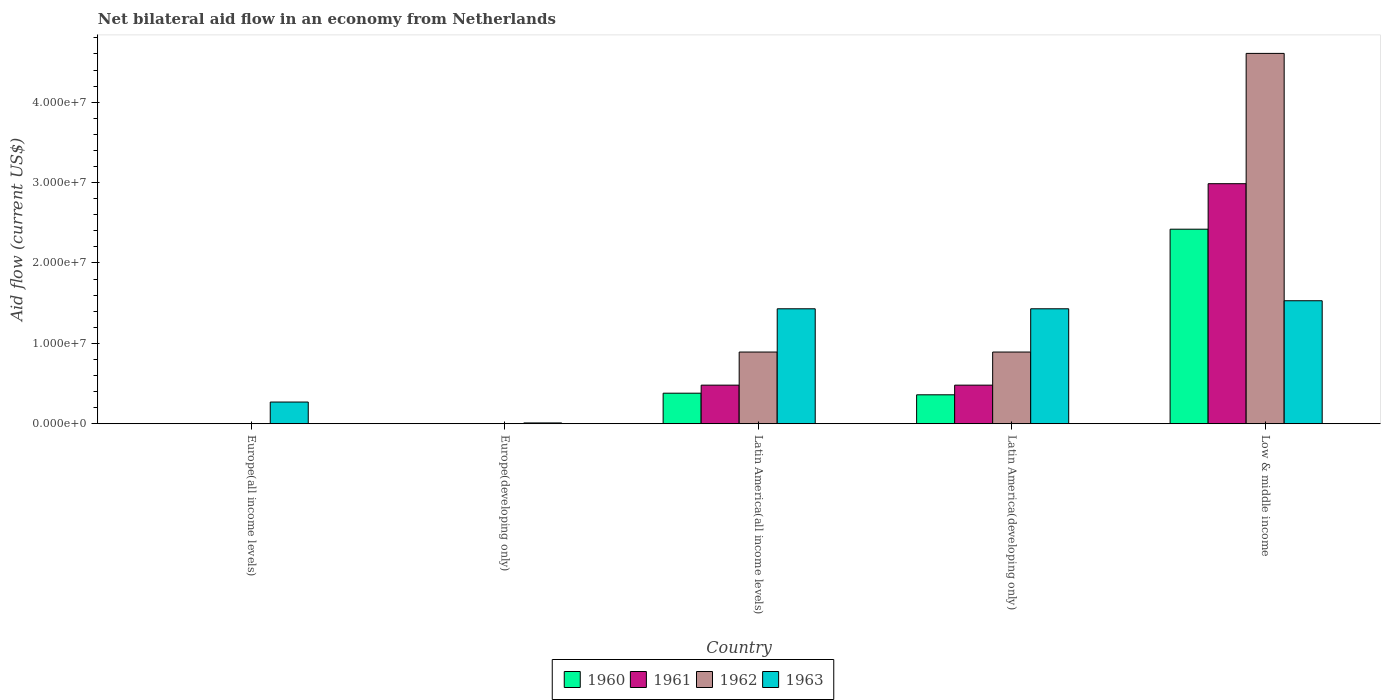Are the number of bars on each tick of the X-axis equal?
Offer a very short reply. No. How many bars are there on the 5th tick from the right?
Provide a succinct answer. 1. What is the label of the 3rd group of bars from the left?
Your answer should be very brief. Latin America(all income levels). In how many cases, is the number of bars for a given country not equal to the number of legend labels?
Keep it short and to the point. 2. Across all countries, what is the maximum net bilateral aid flow in 1961?
Provide a succinct answer. 2.99e+07. Across all countries, what is the minimum net bilateral aid flow in 1962?
Your response must be concise. 0. What is the total net bilateral aid flow in 1960 in the graph?
Provide a succinct answer. 3.16e+07. What is the difference between the net bilateral aid flow in 1963 in Europe(all income levels) and that in Latin America(developing only)?
Provide a succinct answer. -1.16e+07. What is the difference between the net bilateral aid flow in 1963 in Europe(all income levels) and the net bilateral aid flow in 1961 in Low & middle income?
Your answer should be very brief. -2.72e+07. What is the average net bilateral aid flow in 1962 per country?
Offer a very short reply. 1.28e+07. What is the difference between the net bilateral aid flow of/in 1962 and net bilateral aid flow of/in 1963 in Low & middle income?
Ensure brevity in your answer.  3.08e+07. In how many countries, is the net bilateral aid flow in 1963 greater than 20000000 US$?
Your response must be concise. 0. What is the difference between the highest and the second highest net bilateral aid flow in 1963?
Your answer should be very brief. 1.00e+06. What is the difference between the highest and the lowest net bilateral aid flow in 1961?
Offer a very short reply. 2.99e+07. In how many countries, is the net bilateral aid flow in 1961 greater than the average net bilateral aid flow in 1961 taken over all countries?
Ensure brevity in your answer.  1. Is it the case that in every country, the sum of the net bilateral aid flow in 1960 and net bilateral aid flow in 1961 is greater than the net bilateral aid flow in 1963?
Make the answer very short. No. How many bars are there?
Make the answer very short. 14. How many countries are there in the graph?
Your answer should be very brief. 5. What is the difference between two consecutive major ticks on the Y-axis?
Your answer should be compact. 1.00e+07. Does the graph contain grids?
Provide a short and direct response. No. Where does the legend appear in the graph?
Your answer should be very brief. Bottom center. How many legend labels are there?
Offer a terse response. 4. How are the legend labels stacked?
Ensure brevity in your answer.  Horizontal. What is the title of the graph?
Your answer should be compact. Net bilateral aid flow in an economy from Netherlands. Does "2000" appear as one of the legend labels in the graph?
Make the answer very short. No. What is the label or title of the X-axis?
Make the answer very short. Country. What is the Aid flow (current US$) of 1960 in Europe(all income levels)?
Provide a short and direct response. 0. What is the Aid flow (current US$) of 1961 in Europe(all income levels)?
Provide a succinct answer. 0. What is the Aid flow (current US$) of 1962 in Europe(all income levels)?
Keep it short and to the point. 0. What is the Aid flow (current US$) in 1963 in Europe(all income levels)?
Offer a terse response. 2.70e+06. What is the Aid flow (current US$) in 1960 in Europe(developing only)?
Make the answer very short. 0. What is the Aid flow (current US$) in 1963 in Europe(developing only)?
Make the answer very short. 1.00e+05. What is the Aid flow (current US$) in 1960 in Latin America(all income levels)?
Make the answer very short. 3.80e+06. What is the Aid flow (current US$) in 1961 in Latin America(all income levels)?
Provide a succinct answer. 4.80e+06. What is the Aid flow (current US$) of 1962 in Latin America(all income levels)?
Offer a very short reply. 8.92e+06. What is the Aid flow (current US$) in 1963 in Latin America(all income levels)?
Keep it short and to the point. 1.43e+07. What is the Aid flow (current US$) of 1960 in Latin America(developing only)?
Provide a short and direct response. 3.60e+06. What is the Aid flow (current US$) in 1961 in Latin America(developing only)?
Give a very brief answer. 4.80e+06. What is the Aid flow (current US$) in 1962 in Latin America(developing only)?
Provide a short and direct response. 8.92e+06. What is the Aid flow (current US$) of 1963 in Latin America(developing only)?
Ensure brevity in your answer.  1.43e+07. What is the Aid flow (current US$) of 1960 in Low & middle income?
Your answer should be compact. 2.42e+07. What is the Aid flow (current US$) in 1961 in Low & middle income?
Your answer should be compact. 2.99e+07. What is the Aid flow (current US$) of 1962 in Low & middle income?
Your response must be concise. 4.61e+07. What is the Aid flow (current US$) of 1963 in Low & middle income?
Your response must be concise. 1.53e+07. Across all countries, what is the maximum Aid flow (current US$) in 1960?
Make the answer very short. 2.42e+07. Across all countries, what is the maximum Aid flow (current US$) in 1961?
Your answer should be compact. 2.99e+07. Across all countries, what is the maximum Aid flow (current US$) in 1962?
Your answer should be compact. 4.61e+07. Across all countries, what is the maximum Aid flow (current US$) in 1963?
Offer a terse response. 1.53e+07. Across all countries, what is the minimum Aid flow (current US$) in 1963?
Make the answer very short. 1.00e+05. What is the total Aid flow (current US$) of 1960 in the graph?
Your response must be concise. 3.16e+07. What is the total Aid flow (current US$) in 1961 in the graph?
Give a very brief answer. 3.95e+07. What is the total Aid flow (current US$) in 1962 in the graph?
Your answer should be very brief. 6.39e+07. What is the total Aid flow (current US$) of 1963 in the graph?
Provide a succinct answer. 4.67e+07. What is the difference between the Aid flow (current US$) of 1963 in Europe(all income levels) and that in Europe(developing only)?
Provide a succinct answer. 2.60e+06. What is the difference between the Aid flow (current US$) in 1963 in Europe(all income levels) and that in Latin America(all income levels)?
Ensure brevity in your answer.  -1.16e+07. What is the difference between the Aid flow (current US$) of 1963 in Europe(all income levels) and that in Latin America(developing only)?
Ensure brevity in your answer.  -1.16e+07. What is the difference between the Aid flow (current US$) in 1963 in Europe(all income levels) and that in Low & middle income?
Keep it short and to the point. -1.26e+07. What is the difference between the Aid flow (current US$) of 1963 in Europe(developing only) and that in Latin America(all income levels)?
Offer a very short reply. -1.42e+07. What is the difference between the Aid flow (current US$) in 1963 in Europe(developing only) and that in Latin America(developing only)?
Your answer should be very brief. -1.42e+07. What is the difference between the Aid flow (current US$) of 1963 in Europe(developing only) and that in Low & middle income?
Your answer should be very brief. -1.52e+07. What is the difference between the Aid flow (current US$) of 1961 in Latin America(all income levels) and that in Latin America(developing only)?
Provide a succinct answer. 0. What is the difference between the Aid flow (current US$) in 1962 in Latin America(all income levels) and that in Latin America(developing only)?
Offer a very short reply. 0. What is the difference between the Aid flow (current US$) of 1963 in Latin America(all income levels) and that in Latin America(developing only)?
Offer a very short reply. 0. What is the difference between the Aid flow (current US$) in 1960 in Latin America(all income levels) and that in Low & middle income?
Your answer should be very brief. -2.04e+07. What is the difference between the Aid flow (current US$) in 1961 in Latin America(all income levels) and that in Low & middle income?
Make the answer very short. -2.51e+07. What is the difference between the Aid flow (current US$) of 1962 in Latin America(all income levels) and that in Low & middle income?
Make the answer very short. -3.72e+07. What is the difference between the Aid flow (current US$) of 1963 in Latin America(all income levels) and that in Low & middle income?
Provide a succinct answer. -1.00e+06. What is the difference between the Aid flow (current US$) of 1960 in Latin America(developing only) and that in Low & middle income?
Your response must be concise. -2.06e+07. What is the difference between the Aid flow (current US$) of 1961 in Latin America(developing only) and that in Low & middle income?
Offer a very short reply. -2.51e+07. What is the difference between the Aid flow (current US$) of 1962 in Latin America(developing only) and that in Low & middle income?
Your answer should be compact. -3.72e+07. What is the difference between the Aid flow (current US$) of 1960 in Latin America(all income levels) and the Aid flow (current US$) of 1961 in Latin America(developing only)?
Your response must be concise. -1.00e+06. What is the difference between the Aid flow (current US$) in 1960 in Latin America(all income levels) and the Aid flow (current US$) in 1962 in Latin America(developing only)?
Offer a terse response. -5.12e+06. What is the difference between the Aid flow (current US$) in 1960 in Latin America(all income levels) and the Aid flow (current US$) in 1963 in Latin America(developing only)?
Provide a succinct answer. -1.05e+07. What is the difference between the Aid flow (current US$) of 1961 in Latin America(all income levels) and the Aid flow (current US$) of 1962 in Latin America(developing only)?
Keep it short and to the point. -4.12e+06. What is the difference between the Aid flow (current US$) in 1961 in Latin America(all income levels) and the Aid flow (current US$) in 1963 in Latin America(developing only)?
Offer a very short reply. -9.50e+06. What is the difference between the Aid flow (current US$) in 1962 in Latin America(all income levels) and the Aid flow (current US$) in 1963 in Latin America(developing only)?
Provide a short and direct response. -5.38e+06. What is the difference between the Aid flow (current US$) in 1960 in Latin America(all income levels) and the Aid flow (current US$) in 1961 in Low & middle income?
Offer a terse response. -2.61e+07. What is the difference between the Aid flow (current US$) of 1960 in Latin America(all income levels) and the Aid flow (current US$) of 1962 in Low & middle income?
Offer a very short reply. -4.23e+07. What is the difference between the Aid flow (current US$) of 1960 in Latin America(all income levels) and the Aid flow (current US$) of 1963 in Low & middle income?
Provide a succinct answer. -1.15e+07. What is the difference between the Aid flow (current US$) of 1961 in Latin America(all income levels) and the Aid flow (current US$) of 1962 in Low & middle income?
Provide a succinct answer. -4.13e+07. What is the difference between the Aid flow (current US$) of 1961 in Latin America(all income levels) and the Aid flow (current US$) of 1963 in Low & middle income?
Keep it short and to the point. -1.05e+07. What is the difference between the Aid flow (current US$) in 1962 in Latin America(all income levels) and the Aid flow (current US$) in 1963 in Low & middle income?
Ensure brevity in your answer.  -6.38e+06. What is the difference between the Aid flow (current US$) in 1960 in Latin America(developing only) and the Aid flow (current US$) in 1961 in Low & middle income?
Provide a short and direct response. -2.63e+07. What is the difference between the Aid flow (current US$) of 1960 in Latin America(developing only) and the Aid flow (current US$) of 1962 in Low & middle income?
Offer a very short reply. -4.25e+07. What is the difference between the Aid flow (current US$) in 1960 in Latin America(developing only) and the Aid flow (current US$) in 1963 in Low & middle income?
Provide a short and direct response. -1.17e+07. What is the difference between the Aid flow (current US$) of 1961 in Latin America(developing only) and the Aid flow (current US$) of 1962 in Low & middle income?
Your answer should be very brief. -4.13e+07. What is the difference between the Aid flow (current US$) of 1961 in Latin America(developing only) and the Aid flow (current US$) of 1963 in Low & middle income?
Offer a terse response. -1.05e+07. What is the difference between the Aid flow (current US$) in 1962 in Latin America(developing only) and the Aid flow (current US$) in 1963 in Low & middle income?
Your answer should be very brief. -6.38e+06. What is the average Aid flow (current US$) in 1960 per country?
Your answer should be very brief. 6.32e+06. What is the average Aid flow (current US$) in 1961 per country?
Ensure brevity in your answer.  7.89e+06. What is the average Aid flow (current US$) in 1962 per country?
Make the answer very short. 1.28e+07. What is the average Aid flow (current US$) of 1963 per country?
Your response must be concise. 9.34e+06. What is the difference between the Aid flow (current US$) in 1960 and Aid flow (current US$) in 1962 in Latin America(all income levels)?
Your response must be concise. -5.12e+06. What is the difference between the Aid flow (current US$) in 1960 and Aid flow (current US$) in 1963 in Latin America(all income levels)?
Your answer should be very brief. -1.05e+07. What is the difference between the Aid flow (current US$) in 1961 and Aid flow (current US$) in 1962 in Latin America(all income levels)?
Ensure brevity in your answer.  -4.12e+06. What is the difference between the Aid flow (current US$) in 1961 and Aid flow (current US$) in 1963 in Latin America(all income levels)?
Give a very brief answer. -9.50e+06. What is the difference between the Aid flow (current US$) of 1962 and Aid flow (current US$) of 1963 in Latin America(all income levels)?
Your answer should be very brief. -5.38e+06. What is the difference between the Aid flow (current US$) of 1960 and Aid flow (current US$) of 1961 in Latin America(developing only)?
Keep it short and to the point. -1.20e+06. What is the difference between the Aid flow (current US$) of 1960 and Aid flow (current US$) of 1962 in Latin America(developing only)?
Your response must be concise. -5.32e+06. What is the difference between the Aid flow (current US$) of 1960 and Aid flow (current US$) of 1963 in Latin America(developing only)?
Provide a succinct answer. -1.07e+07. What is the difference between the Aid flow (current US$) in 1961 and Aid flow (current US$) in 1962 in Latin America(developing only)?
Offer a terse response. -4.12e+06. What is the difference between the Aid flow (current US$) in 1961 and Aid flow (current US$) in 1963 in Latin America(developing only)?
Offer a terse response. -9.50e+06. What is the difference between the Aid flow (current US$) of 1962 and Aid flow (current US$) of 1963 in Latin America(developing only)?
Keep it short and to the point. -5.38e+06. What is the difference between the Aid flow (current US$) of 1960 and Aid flow (current US$) of 1961 in Low & middle income?
Your answer should be very brief. -5.66e+06. What is the difference between the Aid flow (current US$) of 1960 and Aid flow (current US$) of 1962 in Low & middle income?
Your answer should be very brief. -2.19e+07. What is the difference between the Aid flow (current US$) in 1960 and Aid flow (current US$) in 1963 in Low & middle income?
Give a very brief answer. 8.90e+06. What is the difference between the Aid flow (current US$) of 1961 and Aid flow (current US$) of 1962 in Low & middle income?
Keep it short and to the point. -1.62e+07. What is the difference between the Aid flow (current US$) of 1961 and Aid flow (current US$) of 1963 in Low & middle income?
Your answer should be compact. 1.46e+07. What is the difference between the Aid flow (current US$) in 1962 and Aid flow (current US$) in 1963 in Low & middle income?
Ensure brevity in your answer.  3.08e+07. What is the ratio of the Aid flow (current US$) of 1963 in Europe(all income levels) to that in Europe(developing only)?
Make the answer very short. 27. What is the ratio of the Aid flow (current US$) in 1963 in Europe(all income levels) to that in Latin America(all income levels)?
Give a very brief answer. 0.19. What is the ratio of the Aid flow (current US$) in 1963 in Europe(all income levels) to that in Latin America(developing only)?
Your response must be concise. 0.19. What is the ratio of the Aid flow (current US$) of 1963 in Europe(all income levels) to that in Low & middle income?
Ensure brevity in your answer.  0.18. What is the ratio of the Aid flow (current US$) in 1963 in Europe(developing only) to that in Latin America(all income levels)?
Make the answer very short. 0.01. What is the ratio of the Aid flow (current US$) in 1963 in Europe(developing only) to that in Latin America(developing only)?
Provide a short and direct response. 0.01. What is the ratio of the Aid flow (current US$) of 1963 in Europe(developing only) to that in Low & middle income?
Ensure brevity in your answer.  0.01. What is the ratio of the Aid flow (current US$) of 1960 in Latin America(all income levels) to that in Latin America(developing only)?
Your answer should be very brief. 1.06. What is the ratio of the Aid flow (current US$) of 1960 in Latin America(all income levels) to that in Low & middle income?
Offer a terse response. 0.16. What is the ratio of the Aid flow (current US$) in 1961 in Latin America(all income levels) to that in Low & middle income?
Give a very brief answer. 0.16. What is the ratio of the Aid flow (current US$) of 1962 in Latin America(all income levels) to that in Low & middle income?
Your answer should be very brief. 0.19. What is the ratio of the Aid flow (current US$) of 1963 in Latin America(all income levels) to that in Low & middle income?
Keep it short and to the point. 0.93. What is the ratio of the Aid flow (current US$) in 1960 in Latin America(developing only) to that in Low & middle income?
Your response must be concise. 0.15. What is the ratio of the Aid flow (current US$) of 1961 in Latin America(developing only) to that in Low & middle income?
Offer a very short reply. 0.16. What is the ratio of the Aid flow (current US$) in 1962 in Latin America(developing only) to that in Low & middle income?
Keep it short and to the point. 0.19. What is the ratio of the Aid flow (current US$) in 1963 in Latin America(developing only) to that in Low & middle income?
Provide a short and direct response. 0.93. What is the difference between the highest and the second highest Aid flow (current US$) of 1960?
Give a very brief answer. 2.04e+07. What is the difference between the highest and the second highest Aid flow (current US$) of 1961?
Make the answer very short. 2.51e+07. What is the difference between the highest and the second highest Aid flow (current US$) in 1962?
Offer a terse response. 3.72e+07. What is the difference between the highest and the lowest Aid flow (current US$) in 1960?
Give a very brief answer. 2.42e+07. What is the difference between the highest and the lowest Aid flow (current US$) in 1961?
Your response must be concise. 2.99e+07. What is the difference between the highest and the lowest Aid flow (current US$) of 1962?
Offer a very short reply. 4.61e+07. What is the difference between the highest and the lowest Aid flow (current US$) in 1963?
Your response must be concise. 1.52e+07. 